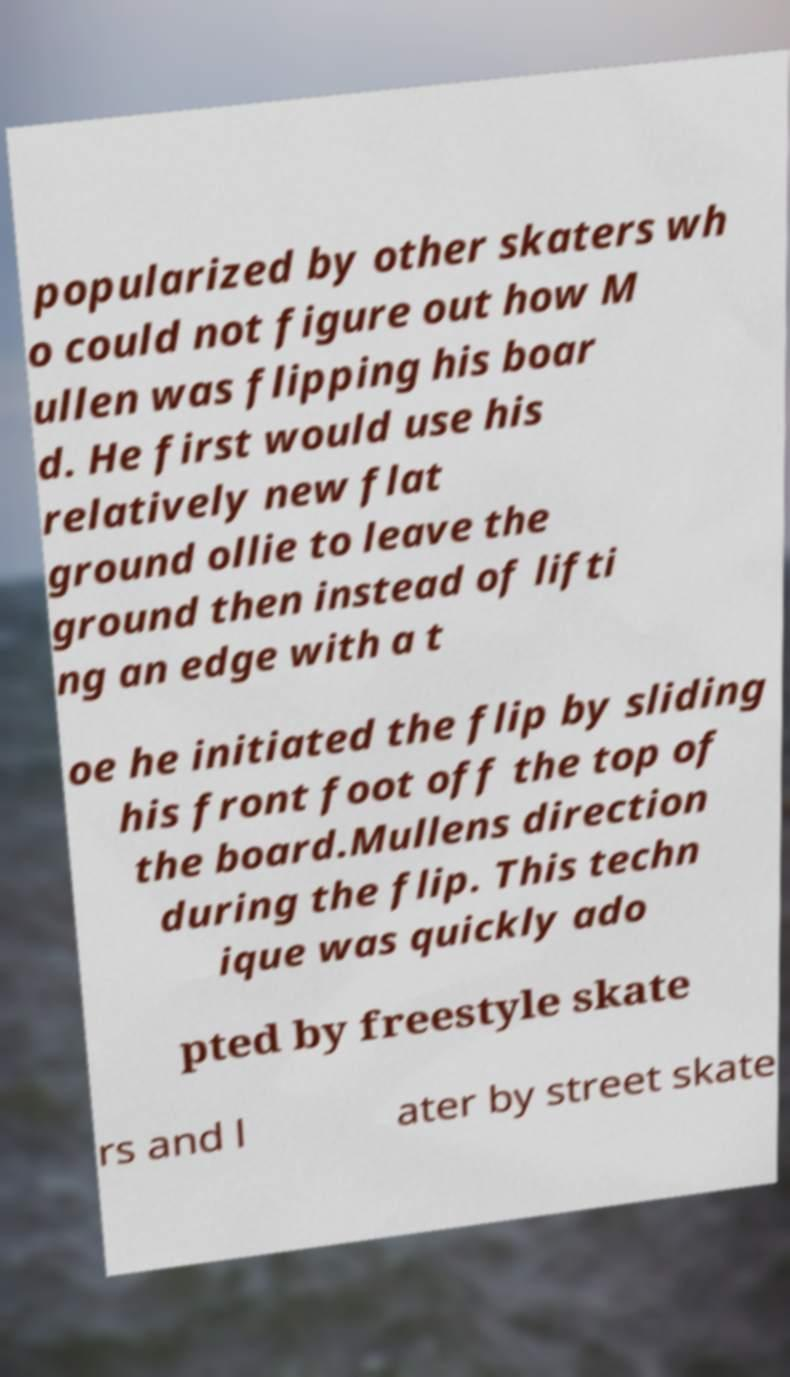Can you read and provide the text displayed in the image?This photo seems to have some interesting text. Can you extract and type it out for me? popularized by other skaters wh o could not figure out how M ullen was flipping his boar d. He first would use his relatively new flat ground ollie to leave the ground then instead of lifti ng an edge with a t oe he initiated the flip by sliding his front foot off the top of the board.Mullens direction during the flip. This techn ique was quickly ado pted by freestyle skate rs and l ater by street skate 